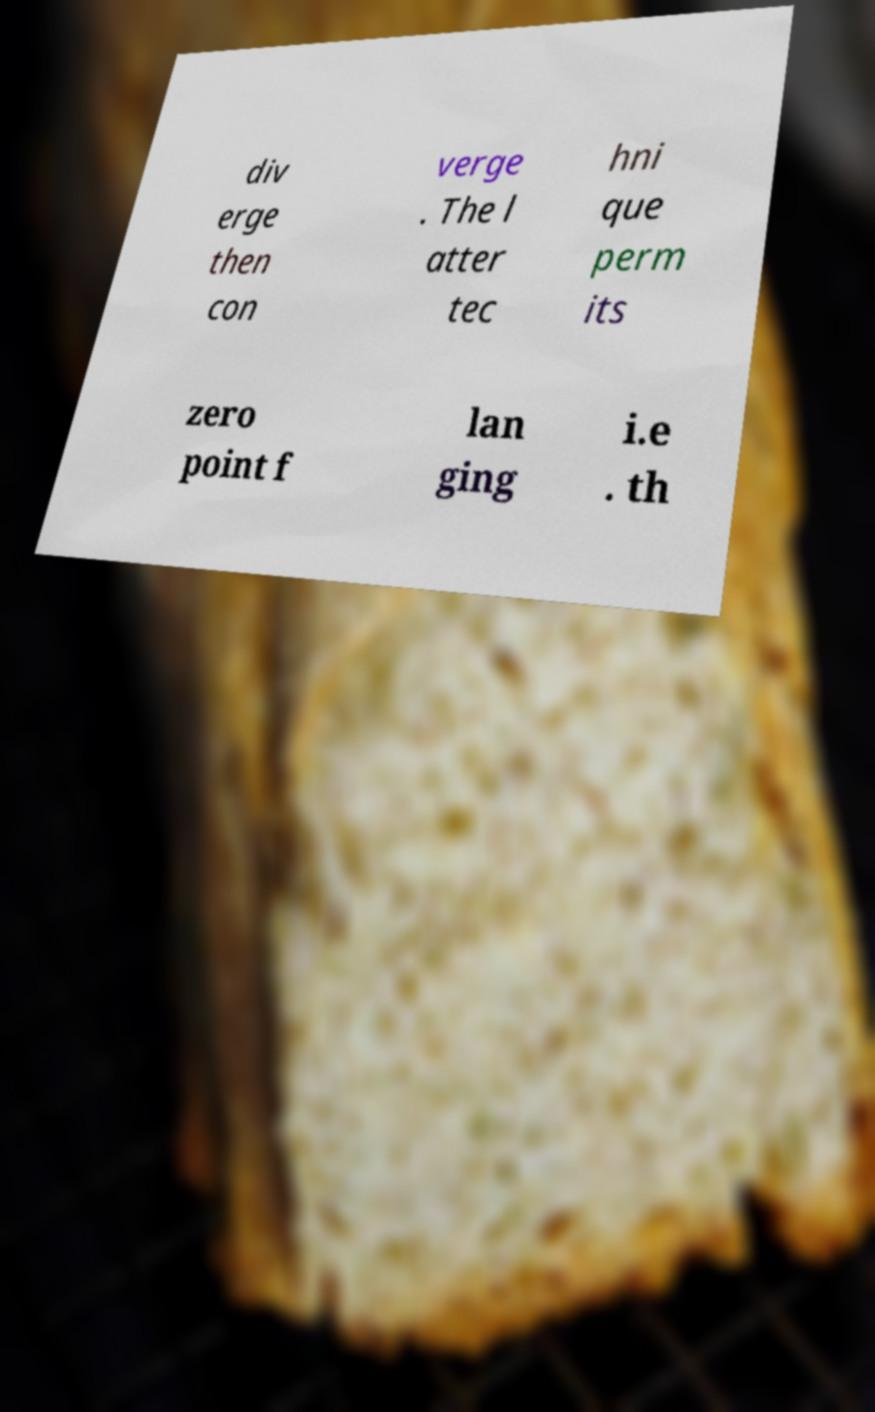I need the written content from this picture converted into text. Can you do that? div erge then con verge . The l atter tec hni que perm its zero point f lan ging i.e . th 